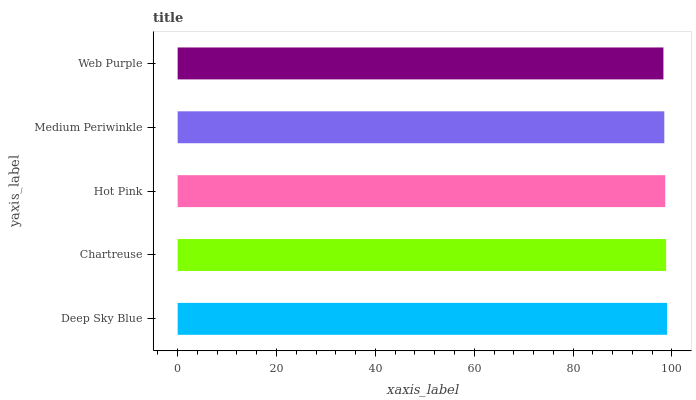Is Web Purple the minimum?
Answer yes or no. Yes. Is Deep Sky Blue the maximum?
Answer yes or no. Yes. Is Chartreuse the minimum?
Answer yes or no. No. Is Chartreuse the maximum?
Answer yes or no. No. Is Deep Sky Blue greater than Chartreuse?
Answer yes or no. Yes. Is Chartreuse less than Deep Sky Blue?
Answer yes or no. Yes. Is Chartreuse greater than Deep Sky Blue?
Answer yes or no. No. Is Deep Sky Blue less than Chartreuse?
Answer yes or no. No. Is Hot Pink the high median?
Answer yes or no. Yes. Is Hot Pink the low median?
Answer yes or no. Yes. Is Chartreuse the high median?
Answer yes or no. No. Is Web Purple the low median?
Answer yes or no. No. 